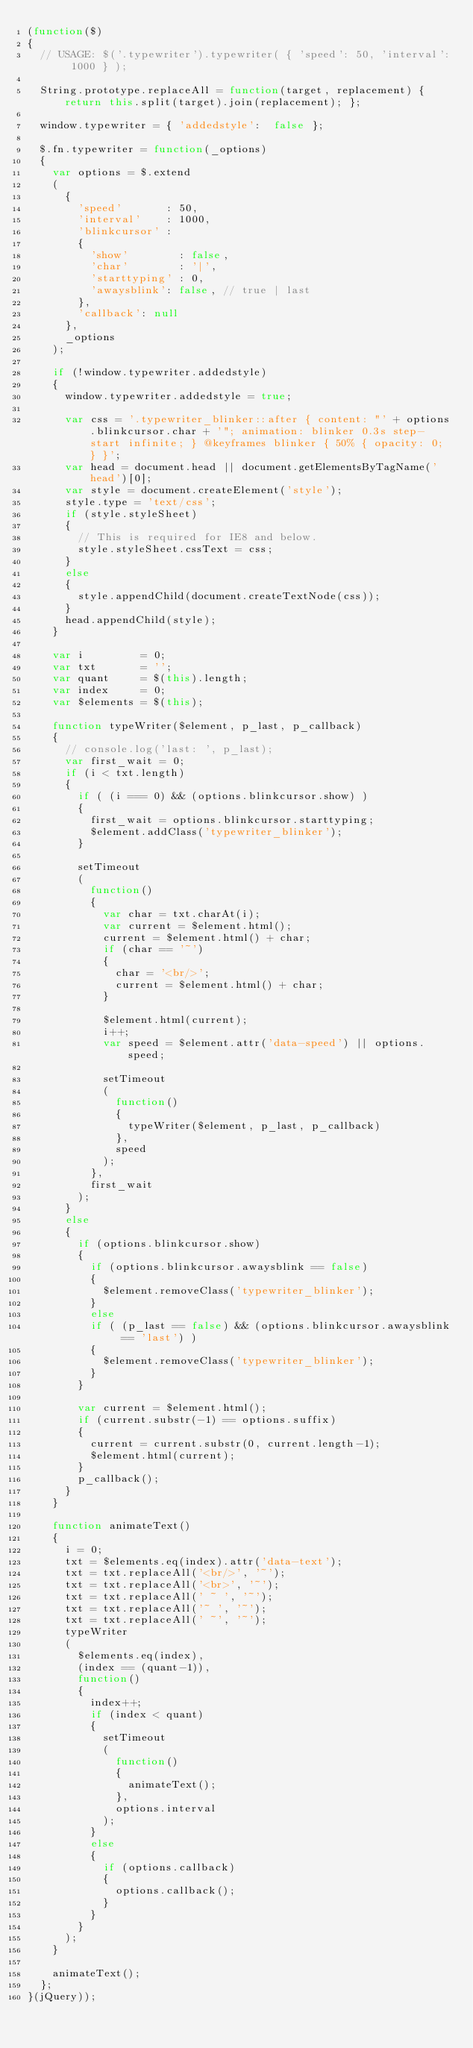<code> <loc_0><loc_0><loc_500><loc_500><_JavaScript_>(function($)
{
	// USAGE: $('.typewriter').typewriter( { 'speed': 50, 'interval': 1000 } );

	String.prototype.replaceAll = function(target, replacement) {  return this.split(target).join(replacement); };

	window.typewriter = { 'addedstyle':  false };

	$.fn.typewriter = function(_options)
	{
		var options = $.extend
		(
			{
				'speed'       : 50,
				'interval'    : 1000,
				'blinkcursor' :
				{
					'show'        : false,
					'char'        : '|',
					'starttyping' : 0,
					'awaysblink': false, // true | last
				},
				'callback': null
			},
			_options
		);

		if (!window.typewriter.addedstyle)
		{
			window.typewriter.addedstyle = true;

			var css = '.typewriter_blinker::after { content: "' + options.blinkcursor.char + '"; animation: blinker 0.3s step-start infinite; } @keyframes blinker { 50% { opacity: 0; } }';
			var head = document.head || document.getElementsByTagName('head')[0];
			var style = document.createElement('style');
			style.type = 'text/css';
			if (style.styleSheet)
			{
				// This is required for IE8 and below.
				style.styleSheet.cssText = css;
			}
			else
			{
				style.appendChild(document.createTextNode(css));
			}
			head.appendChild(style);
		}

		var i         = 0;
		var txt       = '';
		var quant     = $(this).length;
		var index     = 0;
		var $elements = $(this);

		function typeWriter($element, p_last, p_callback)
		{
			// console.log('last: ', p_last);
			var first_wait = 0;
			if (i < txt.length)
			{
				if ( (i === 0) && (options.blinkcursor.show) )
				{
					first_wait = options.blinkcursor.starttyping;
					$element.addClass('typewriter_blinker');
				}

				setTimeout
				(
					function()
					{
						var char = txt.charAt(i);
						var current = $element.html();
						current = $element.html() + char;
						if (char == '~')
						{
							char = '<br/>';
							current = $element.html() + char;
						}

						$element.html(current);
						i++;
						var speed = $element.attr('data-speed') || options.speed;

						setTimeout
						(
							function()
							{
								typeWriter($element, p_last, p_callback)
							},
							speed
						);
					},
					first_wait
				);
			}
			else
			{
				if (options.blinkcursor.show)
				{
					if (options.blinkcursor.awaysblink == false)
					{
						$element.removeClass('typewriter_blinker');
					}
					else
					if ( (p_last == false) && (options.blinkcursor.awaysblink == 'last') )
					{
						$element.removeClass('typewriter_blinker');
					}
				}

				var current = $element.html();
				if (current.substr(-1) == options.suffix)
				{
					current = current.substr(0, current.length-1);
					$element.html(current);
				}
				p_callback();
			}
		}

		function animateText()
		{
			i = 0;
			txt = $elements.eq(index).attr('data-text');
			txt = txt.replaceAll('<br/>', '~');
			txt = txt.replaceAll('<br>', '~');
			txt = txt.replaceAll(' ~ ', '~');
			txt = txt.replaceAll('~ ', '~');
			txt = txt.replaceAll(' ~', '~');
			typeWriter
			(
				$elements.eq(index),
				(index == (quant-1)),
				function()
				{
					index++;
					if (index < quant)
					{
						setTimeout
						(
							function()
							{
								animateText();
							},
							options.interval
						);
					}
					else
					{
						if (options.callback)
						{
							options.callback();
						}
					}
				}
			);
		}

		animateText();
	};
}(jQuery));</code> 